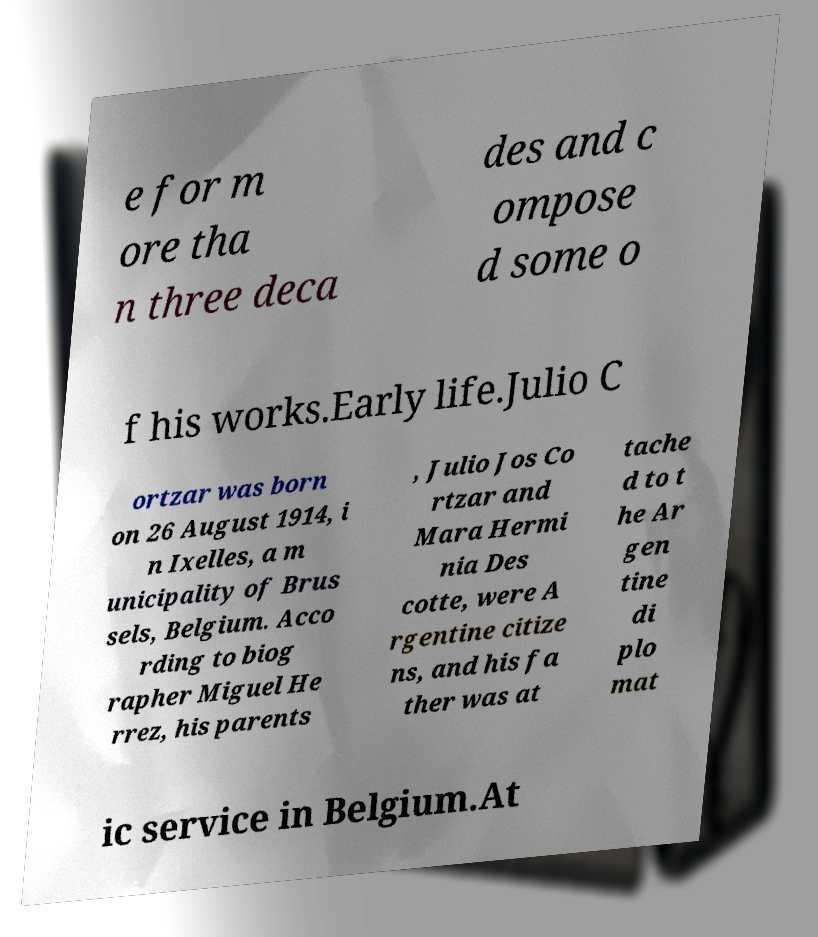Please read and relay the text visible in this image. What does it say? e for m ore tha n three deca des and c ompose d some o f his works.Early life.Julio C ortzar was born on 26 August 1914, i n Ixelles, a m unicipality of Brus sels, Belgium. Acco rding to biog rapher Miguel He rrez, his parents , Julio Jos Co rtzar and Mara Hermi nia Des cotte, were A rgentine citize ns, and his fa ther was at tache d to t he Ar gen tine di plo mat ic service in Belgium.At 